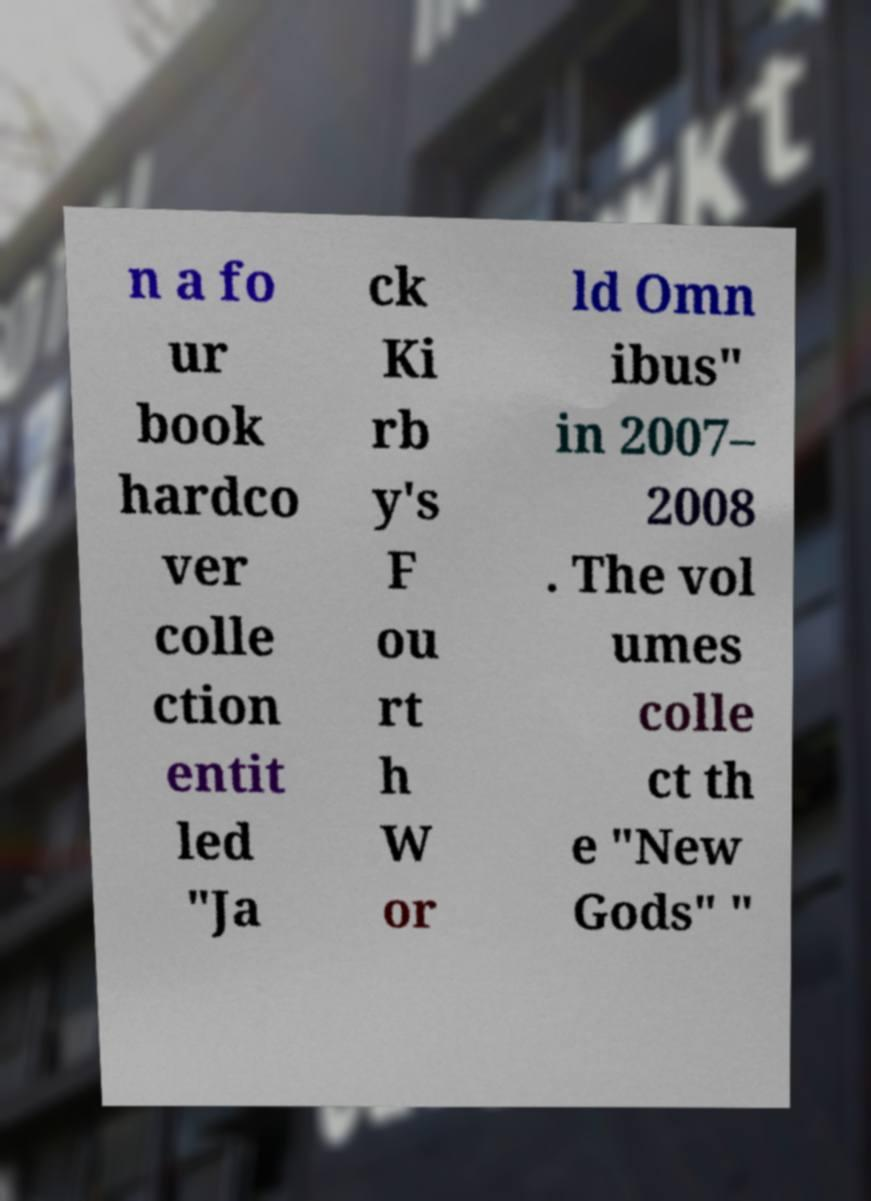Can you accurately transcribe the text from the provided image for me? n a fo ur book hardco ver colle ction entit led "Ja ck Ki rb y's F ou rt h W or ld Omn ibus" in 2007– 2008 . The vol umes colle ct th e "New Gods" " 